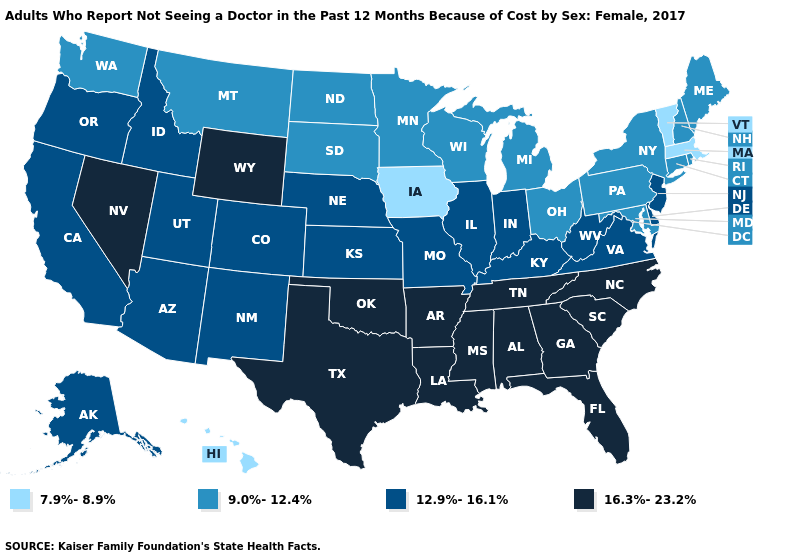Name the states that have a value in the range 12.9%-16.1%?
Short answer required. Alaska, Arizona, California, Colorado, Delaware, Idaho, Illinois, Indiana, Kansas, Kentucky, Missouri, Nebraska, New Jersey, New Mexico, Oregon, Utah, Virginia, West Virginia. Which states have the lowest value in the USA?
Write a very short answer. Hawaii, Iowa, Massachusetts, Vermont. How many symbols are there in the legend?
Write a very short answer. 4. Name the states that have a value in the range 16.3%-23.2%?
Short answer required. Alabama, Arkansas, Florida, Georgia, Louisiana, Mississippi, Nevada, North Carolina, Oklahoma, South Carolina, Tennessee, Texas, Wyoming. Name the states that have a value in the range 9.0%-12.4%?
Keep it brief. Connecticut, Maine, Maryland, Michigan, Minnesota, Montana, New Hampshire, New York, North Dakota, Ohio, Pennsylvania, Rhode Island, South Dakota, Washington, Wisconsin. Does Pennsylvania have the same value as Alaska?
Quick response, please. No. What is the lowest value in the South?
Quick response, please. 9.0%-12.4%. What is the value of New Hampshire?
Short answer required. 9.0%-12.4%. Does Maryland have the lowest value in the South?
Give a very brief answer. Yes. Name the states that have a value in the range 16.3%-23.2%?
Keep it brief. Alabama, Arkansas, Florida, Georgia, Louisiana, Mississippi, Nevada, North Carolina, Oklahoma, South Carolina, Tennessee, Texas, Wyoming. Is the legend a continuous bar?
Concise answer only. No. Among the states that border Idaho , which have the highest value?
Give a very brief answer. Nevada, Wyoming. Name the states that have a value in the range 9.0%-12.4%?
Keep it brief. Connecticut, Maine, Maryland, Michigan, Minnesota, Montana, New Hampshire, New York, North Dakota, Ohio, Pennsylvania, Rhode Island, South Dakota, Washington, Wisconsin. Is the legend a continuous bar?
Answer briefly. No. 